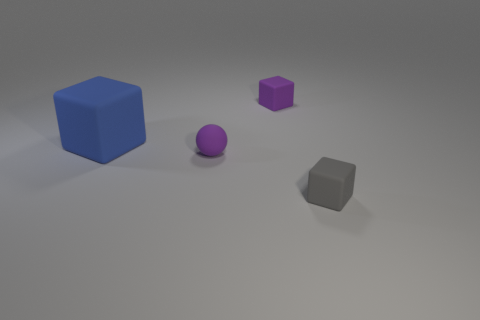Does the image give any clues about what the objects might be used for? The objects don't appear to have any distinct features or markings that would indicate a specific use; they seem to be simple geometric shapes possibly for display, or for use in some form of visual demonstration or educational purpose. 